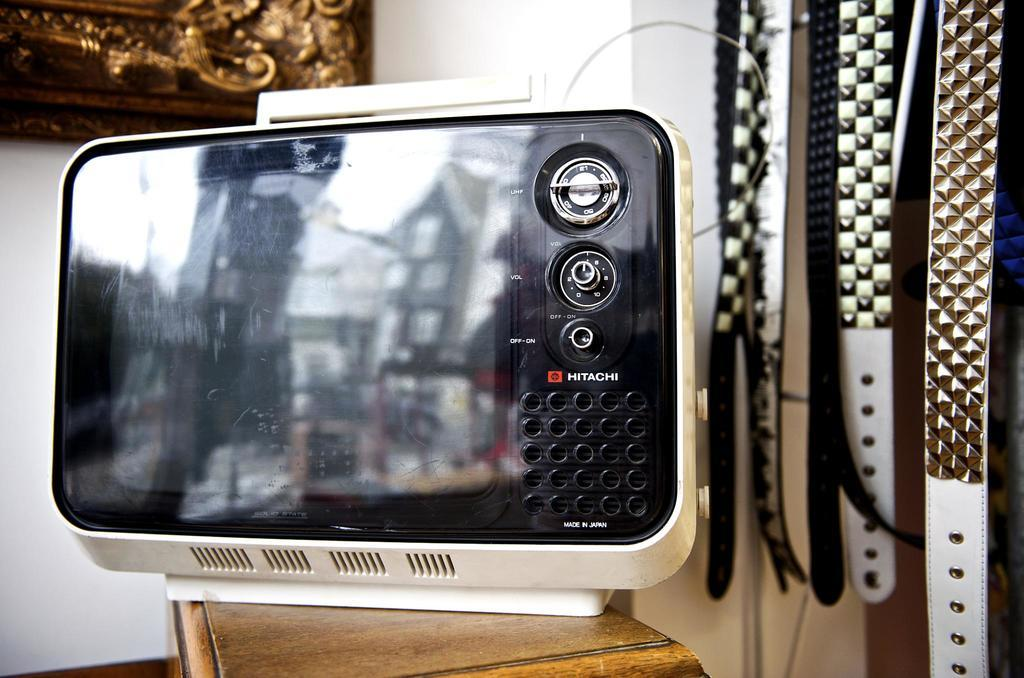<image>
Describe the image concisely. A small Hitachi old fashioned piece of technology sitting on a wooden table. 